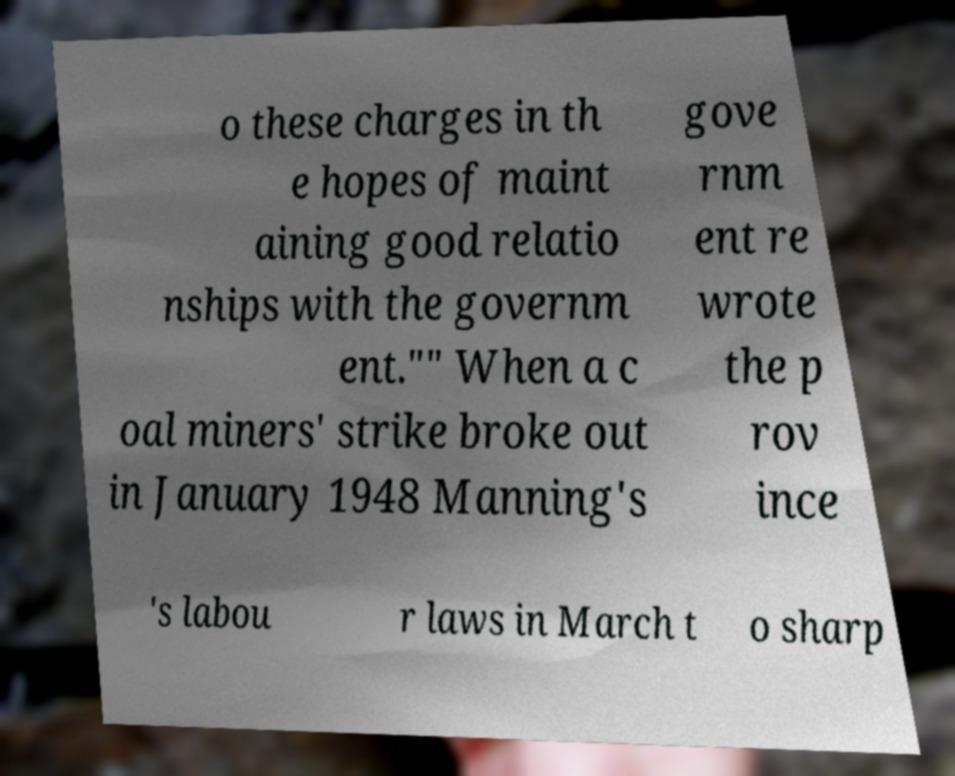Could you assist in decoding the text presented in this image and type it out clearly? o these charges in th e hopes of maint aining good relatio nships with the governm ent."" When a c oal miners' strike broke out in January 1948 Manning's gove rnm ent re wrote the p rov ince 's labou r laws in March t o sharp 